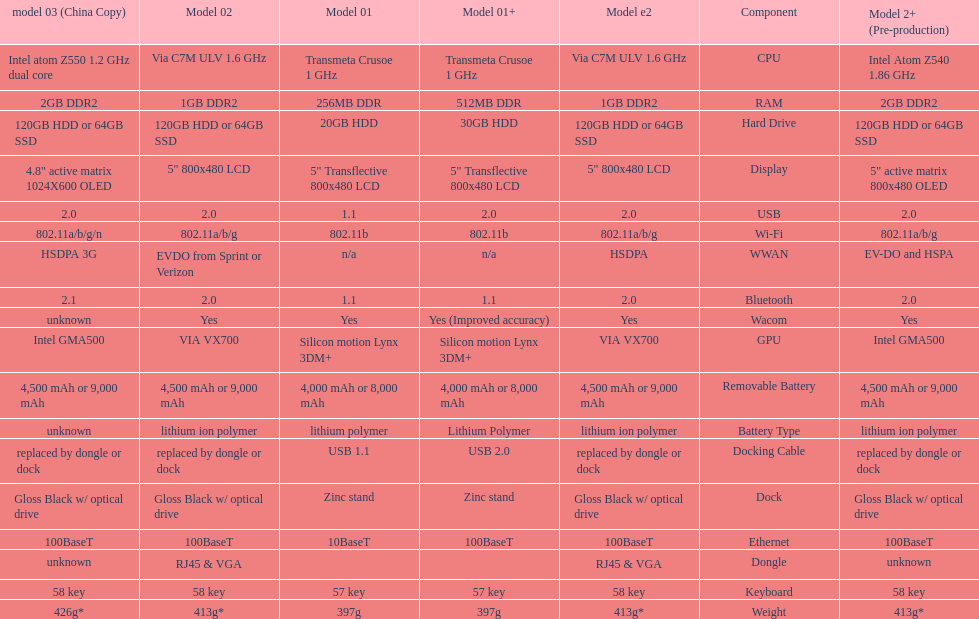What is the next highest hard drive available after the 30gb model? 64GB SSD. Could you parse the entire table as a dict? {'header': ['model 03 (China Copy)', 'Model 02', 'Model 01', 'Model 01+', 'Model e2', 'Component', 'Model 2+ (Pre-production)'], 'rows': [['Intel atom Z550 1.2\xa0GHz dual core', 'Via C7M ULV 1.6\xa0GHz', 'Transmeta Crusoe 1\xa0GHz', 'Transmeta Crusoe 1\xa0GHz', 'Via C7M ULV 1.6\xa0GHz', 'CPU', 'Intel Atom Z540 1.86\xa0GHz'], ['2GB DDR2', '1GB DDR2', '256MB DDR', '512MB DDR', '1GB DDR2', 'RAM', '2GB DDR2'], ['120GB HDD or 64GB SSD', '120GB HDD or 64GB SSD', '20GB HDD', '30GB HDD', '120GB HDD or 64GB SSD', 'Hard Drive', '120GB HDD or 64GB SSD'], ['4.8" active matrix 1024X600 OLED', '5" 800x480 LCD', '5" Transflective 800x480 LCD', '5" Transflective 800x480 LCD', '5" 800x480 LCD', 'Display', '5" active matrix 800x480 OLED'], ['2.0', '2.0', '1.1', '2.0', '2.0', 'USB', '2.0'], ['802.11a/b/g/n', '802.11a/b/g', '802.11b', '802.11b', '802.11a/b/g', 'Wi-Fi', '802.11a/b/g'], ['HSDPA 3G', 'EVDO from Sprint or Verizon', 'n/a', 'n/a', 'HSDPA', 'WWAN', 'EV-DO and HSPA'], ['2.1', '2.0', '1.1', '1.1', '2.0', 'Bluetooth', '2.0'], ['unknown', 'Yes', 'Yes', 'Yes (Improved accuracy)', 'Yes', 'Wacom', 'Yes'], ['Intel GMA500', 'VIA VX700', 'Silicon motion Lynx 3DM+', 'Silicon motion Lynx 3DM+', 'VIA VX700', 'GPU', 'Intel GMA500'], ['4,500 mAh or 9,000 mAh', '4,500 mAh or 9,000 mAh', '4,000 mAh or 8,000 mAh', '4,000 mAh or 8,000 mAh', '4,500 mAh or 9,000 mAh', 'Removable Battery', '4,500 mAh or 9,000 mAh'], ['unknown', 'lithium ion polymer', 'lithium polymer', 'Lithium Polymer', 'lithium ion polymer', 'Battery Type', 'lithium ion polymer'], ['replaced by dongle or dock', 'replaced by dongle or dock', 'USB 1.1', 'USB 2.0', 'replaced by dongle or dock', 'Docking Cable', 'replaced by dongle or dock'], ['Gloss Black w/ optical drive', 'Gloss Black w/ optical drive', 'Zinc stand', 'Zinc stand', 'Gloss Black w/ optical drive', 'Dock', 'Gloss Black w/ optical drive'], ['100BaseT', '100BaseT', '10BaseT', '100BaseT', '100BaseT', 'Ethernet', '100BaseT'], ['unknown', 'RJ45 & VGA', '', '', 'RJ45 & VGA', 'Dongle', 'unknown'], ['58 key', '58 key', '57 key', '57 key', '58 key', 'Keyboard', '58 key'], ['426g*', '413g*', '397g', '397g', '413g*', 'Weight', '413g*']]} 